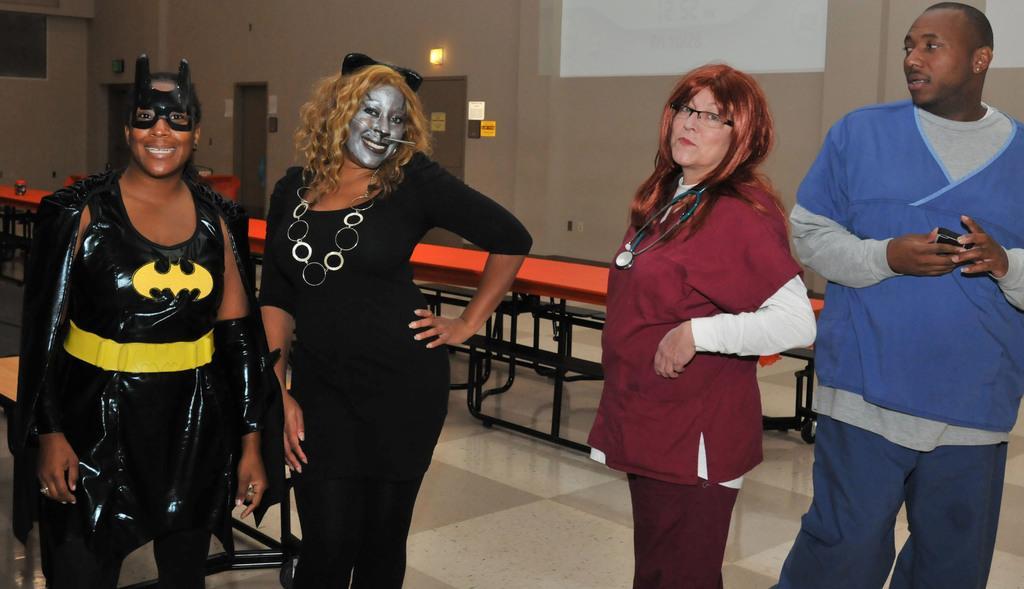In one or two sentences, can you explain what this image depicts? In this image, we can see four persons wearing clothes and standing in front of the wall. There is a table in the middle of the image. 